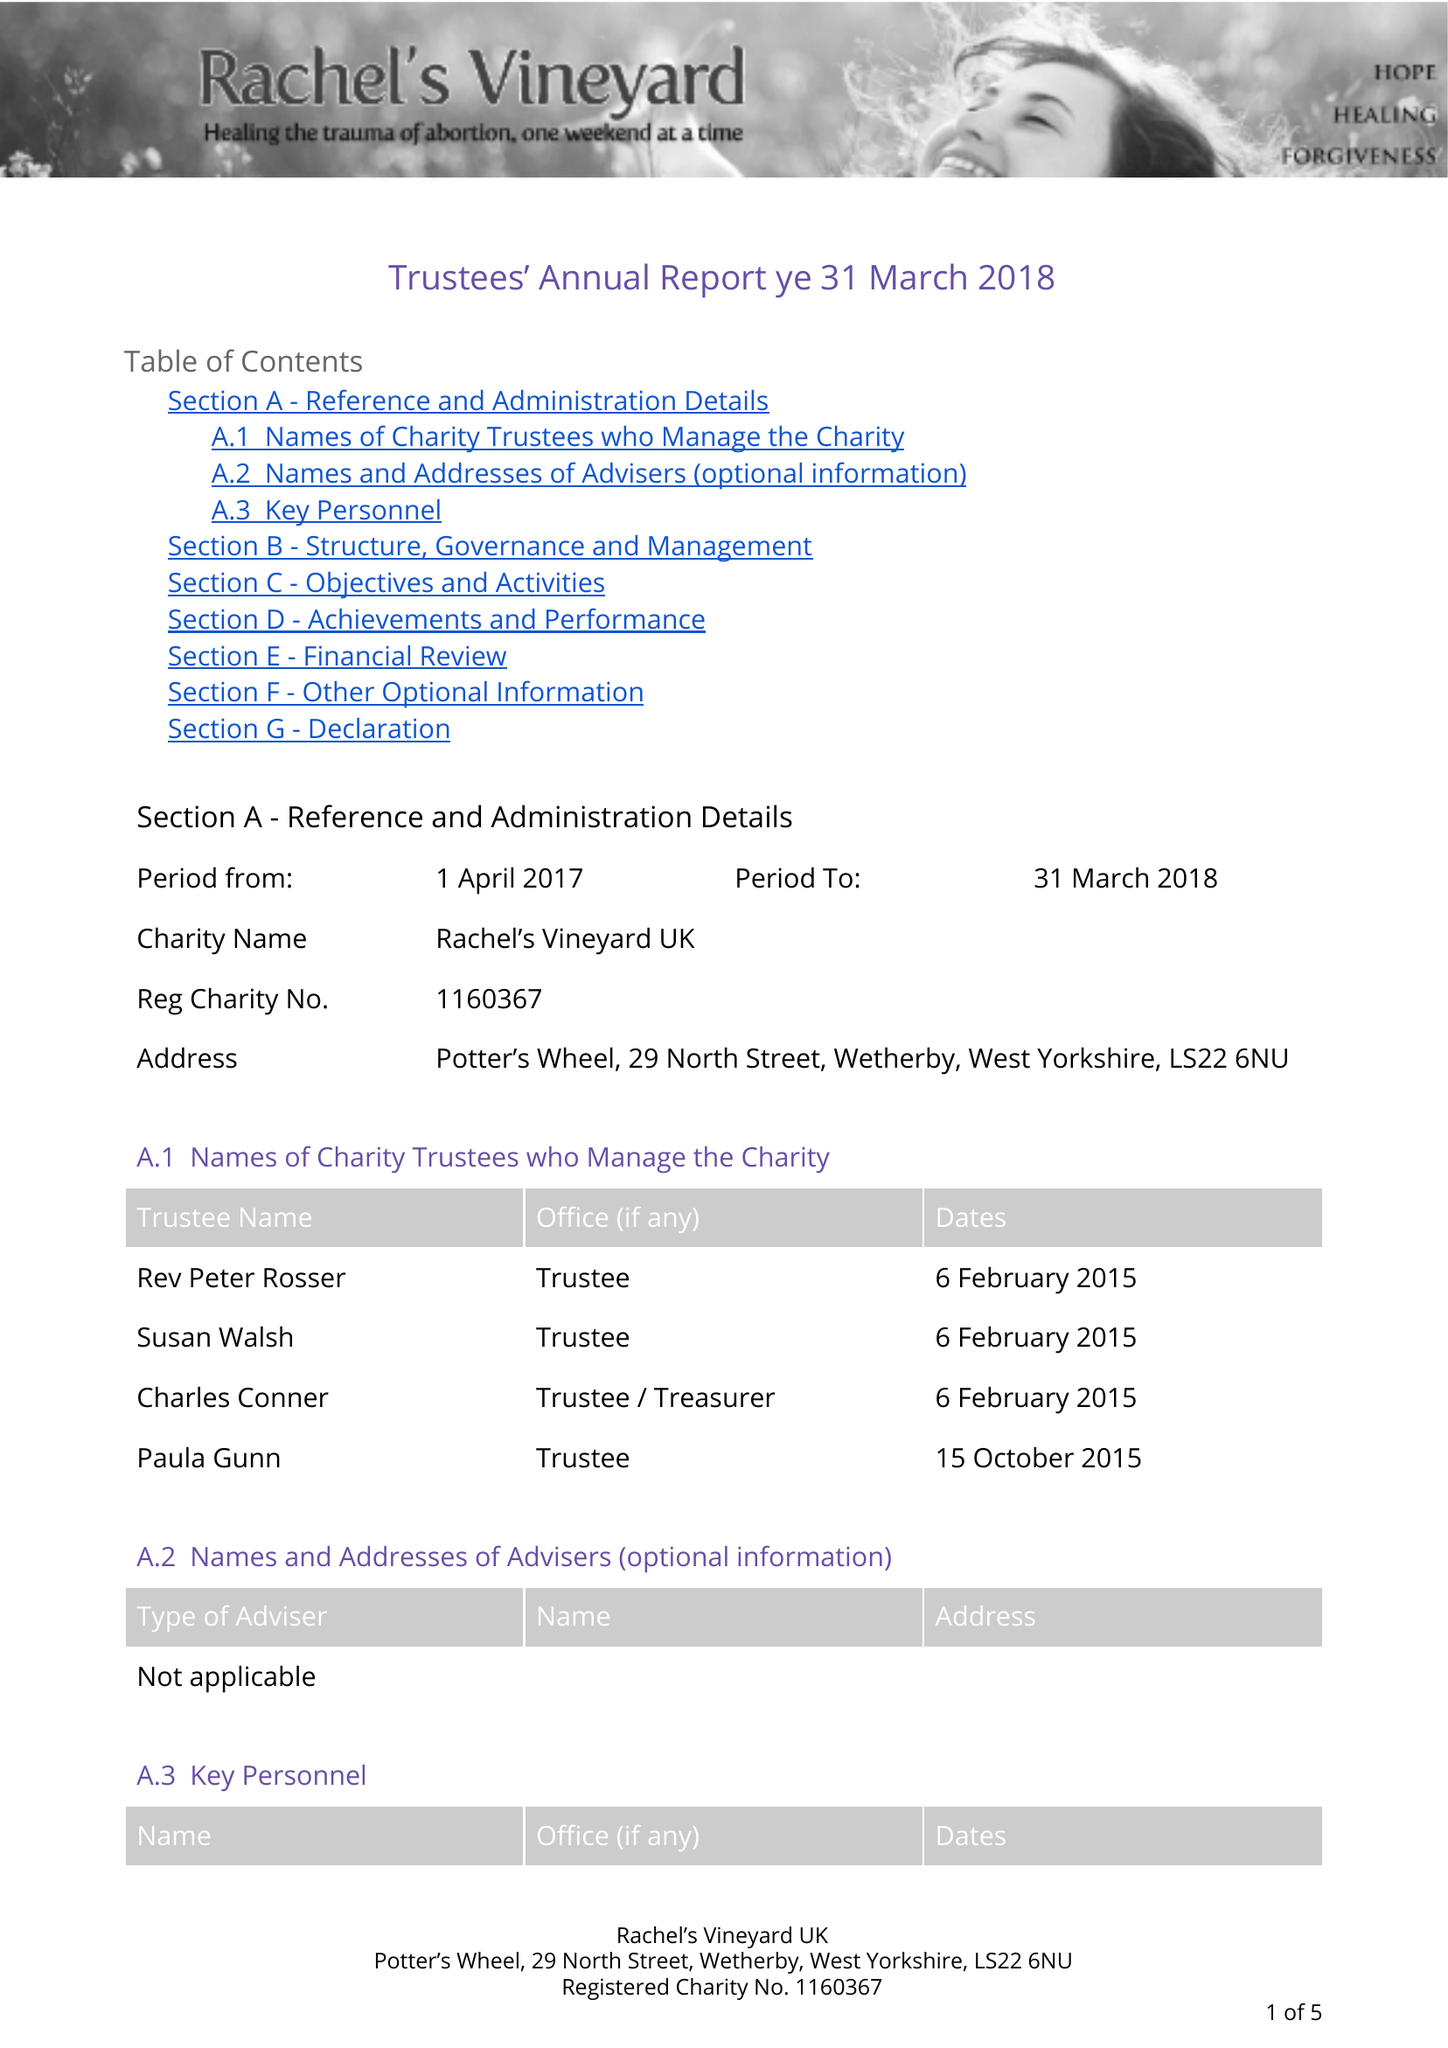What is the value for the spending_annually_in_british_pounds?
Answer the question using a single word or phrase. 13471.00 